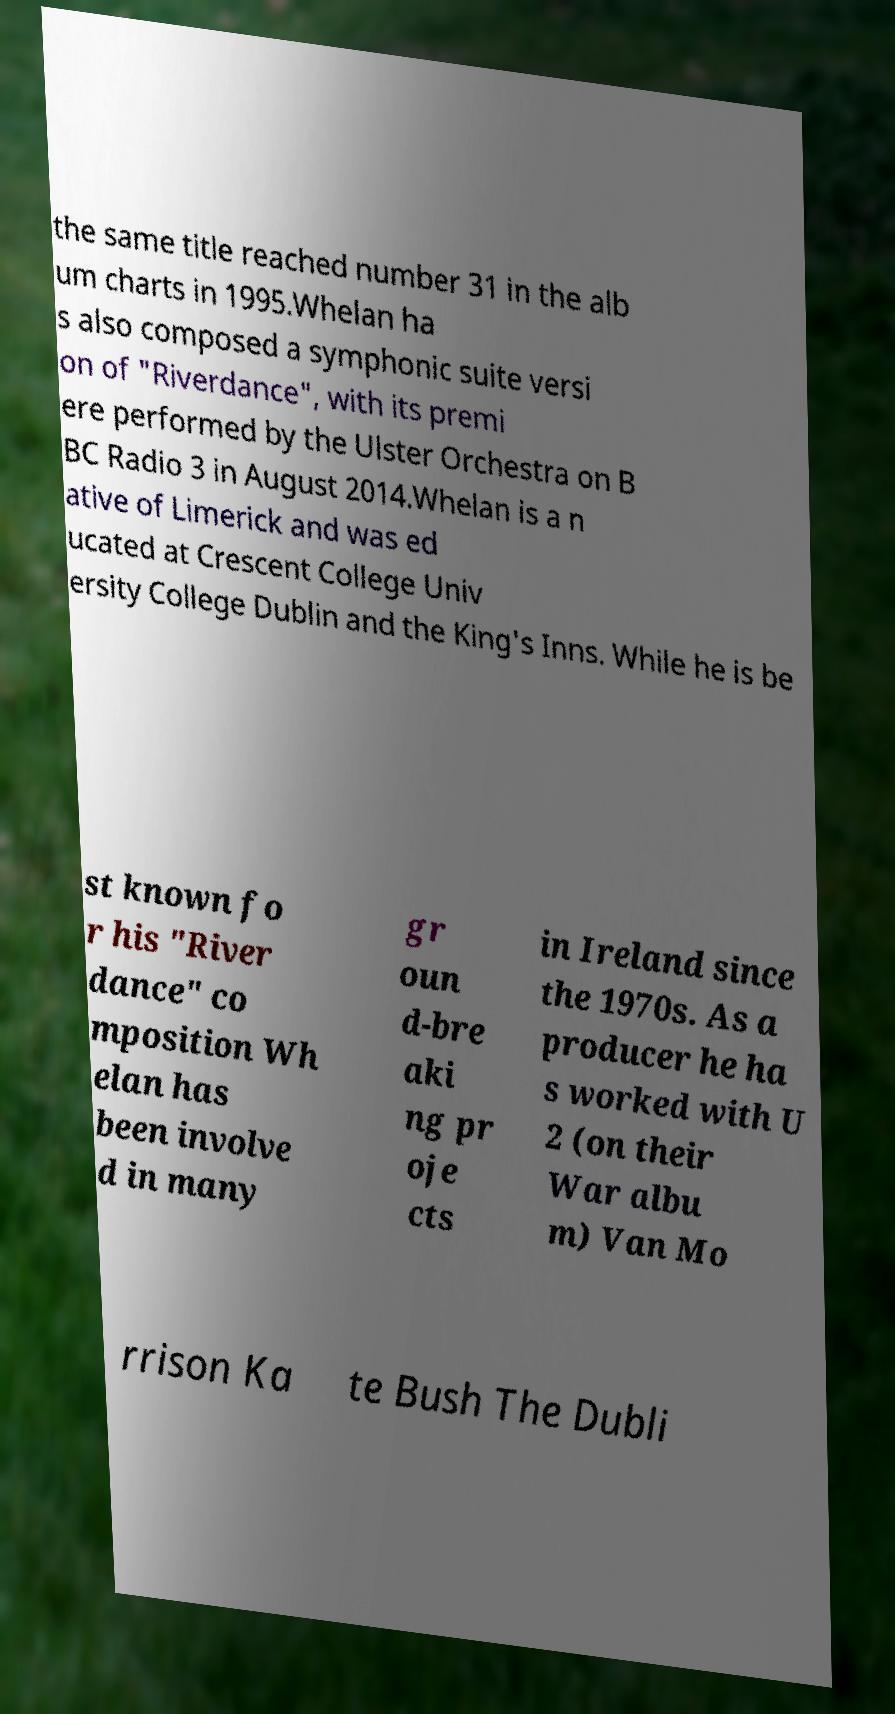There's text embedded in this image that I need extracted. Can you transcribe it verbatim? the same title reached number 31 in the alb um charts in 1995.Whelan ha s also composed a symphonic suite versi on of "Riverdance", with its premi ere performed by the Ulster Orchestra on B BC Radio 3 in August 2014.Whelan is a n ative of Limerick and was ed ucated at Crescent College Univ ersity College Dublin and the King's Inns. While he is be st known fo r his "River dance" co mposition Wh elan has been involve d in many gr oun d-bre aki ng pr oje cts in Ireland since the 1970s. As a producer he ha s worked with U 2 (on their War albu m) Van Mo rrison Ka te Bush The Dubli 